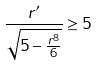Convert formula to latex. <formula><loc_0><loc_0><loc_500><loc_500>\frac { r ^ { \prime } } { \sqrt { 5 - \frac { r ^ { 8 } } { 6 } } } \geq 5</formula> 